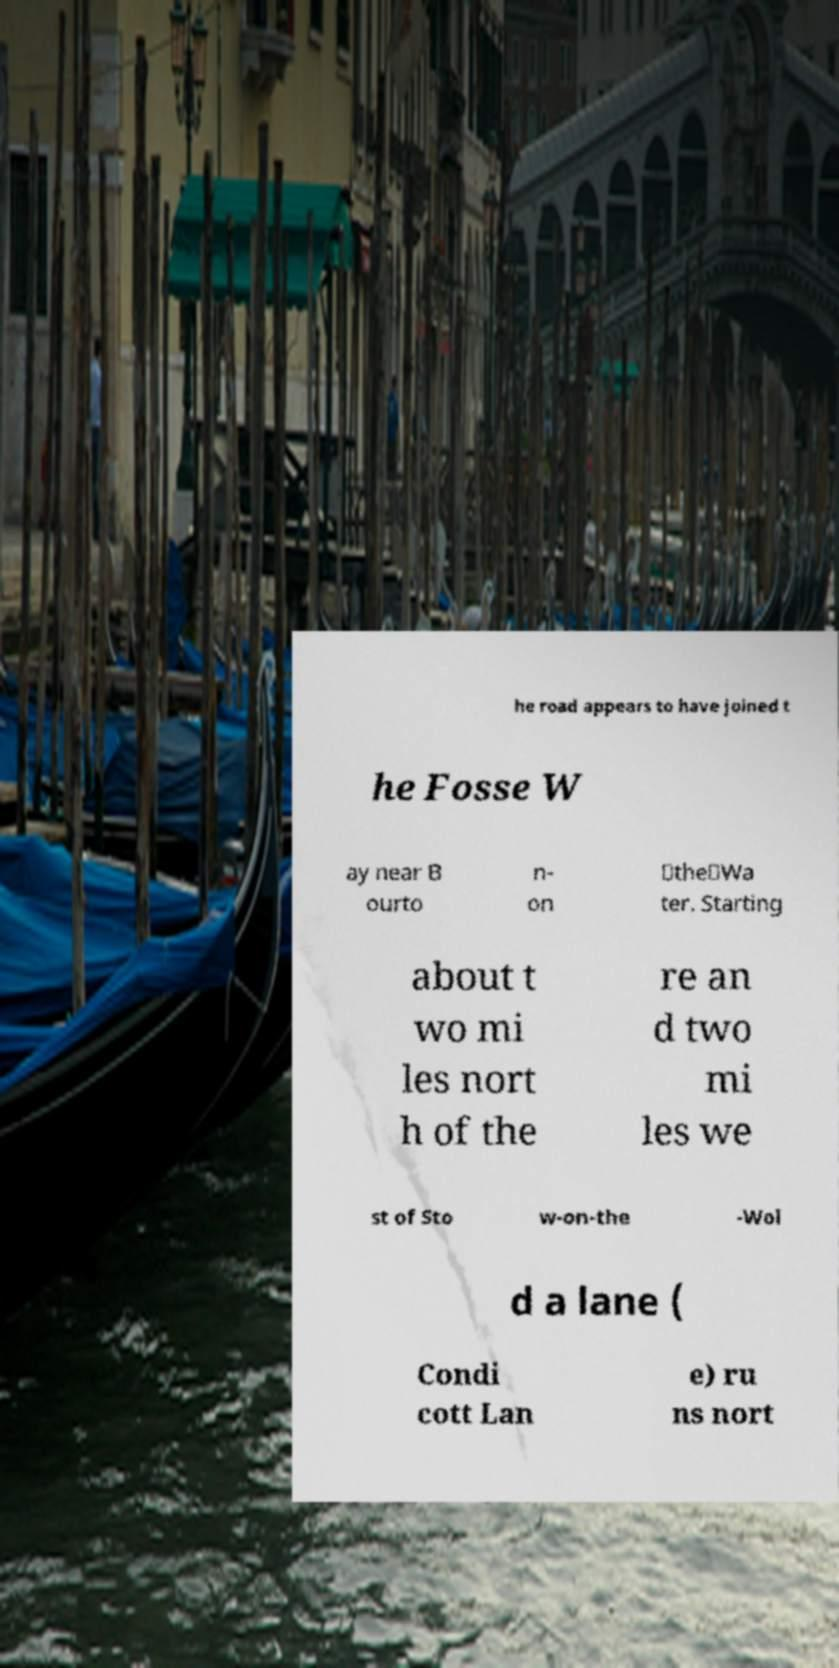Could you extract and type out the text from this image? he road appears to have joined t he Fosse W ay near B ourto n- on ‑the‑Wa ter. Starting about t wo mi les nort h of the re an d two mi les we st of Sto w-on-the -Wol d a lane ( Condi cott Lan e) ru ns nort 